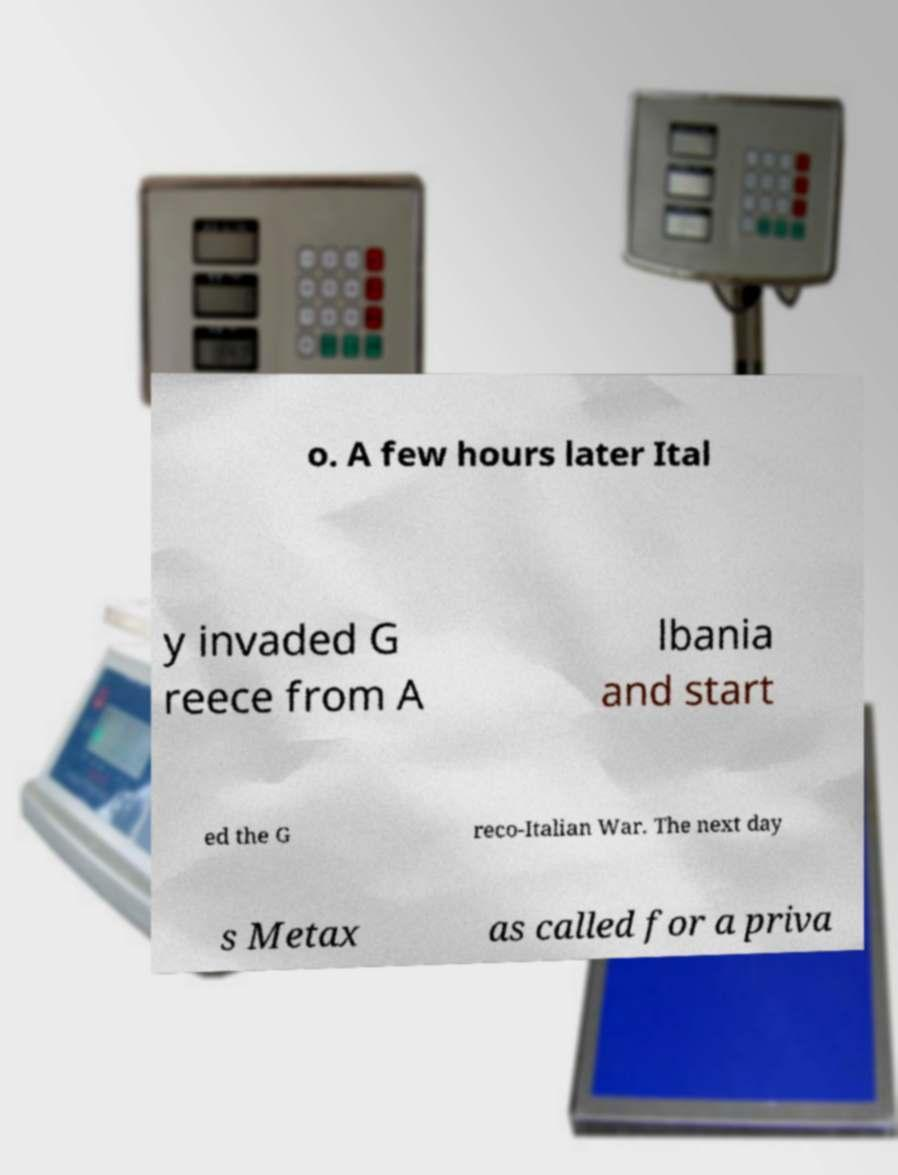Please identify and transcribe the text found in this image. o. A few hours later Ital y invaded G reece from A lbania and start ed the G reco-Italian War. The next day s Metax as called for a priva 